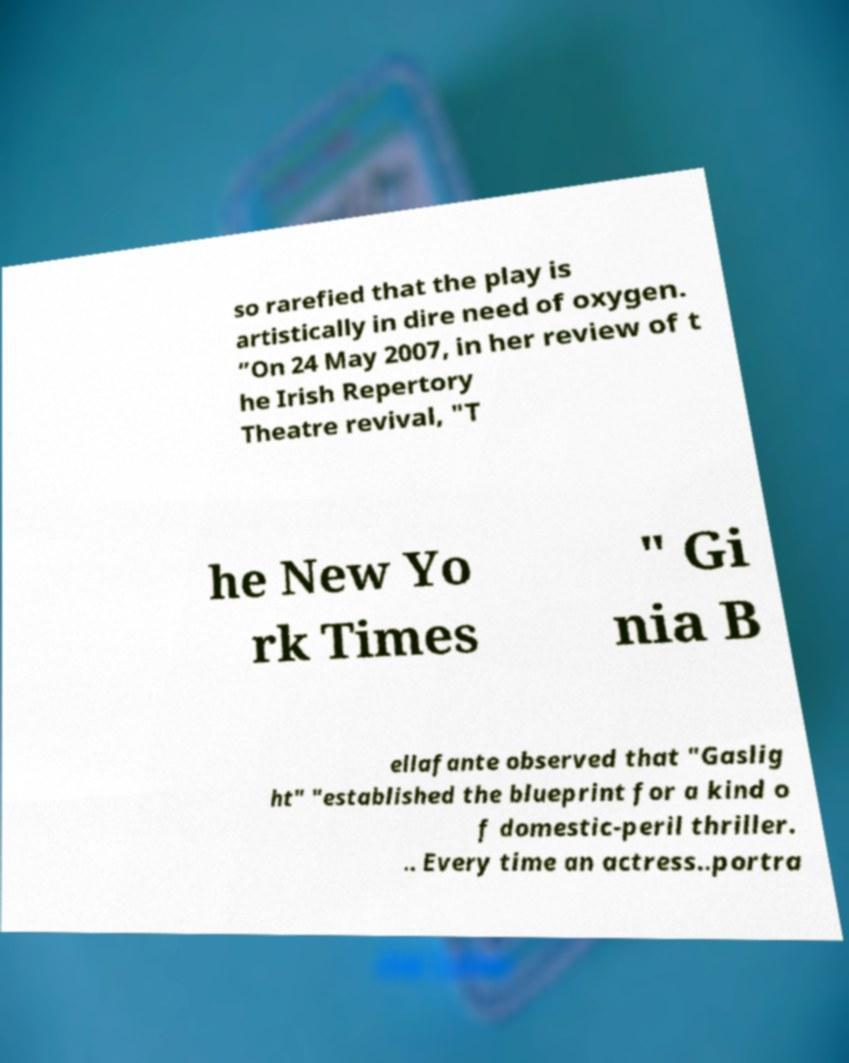Could you assist in decoding the text presented in this image and type it out clearly? so rarefied that the play is artistically in dire need of oxygen. ”On 24 May 2007, in her review of t he Irish Repertory Theatre revival, "T he New Yo rk Times " Gi nia B ellafante observed that "Gaslig ht" "established the blueprint for a kind o f domestic-peril thriller. .. Every time an actress..portra 